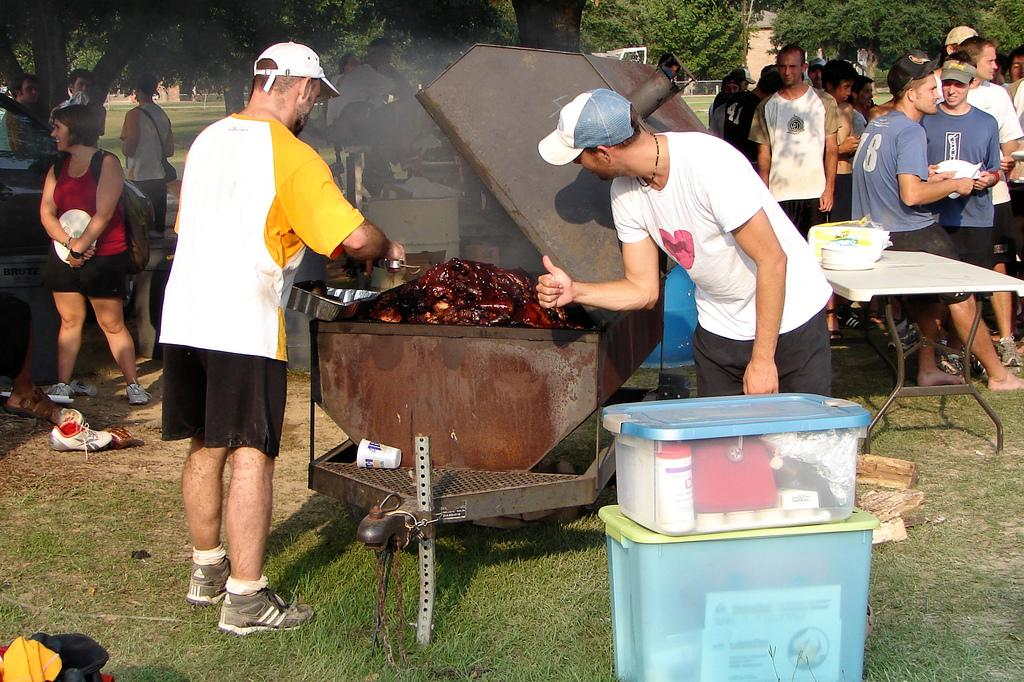<image>
Present a compact description of the photo's key features. A gathering of people at a barbecue and one man with a number 18 on his shirt 